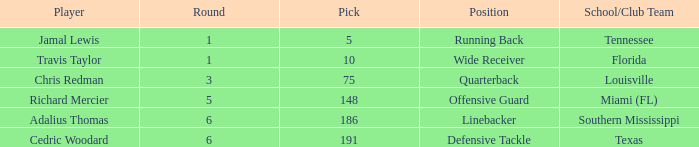What's the highest round that louisville drafted into when their pick was over 75? None. 